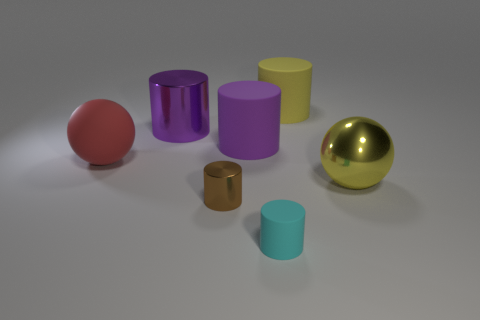Which object in the image is the largest by volume? The largest object by volume appears to be the purple cylinder, as it has both a significant height and diameter compared to the other objects. 